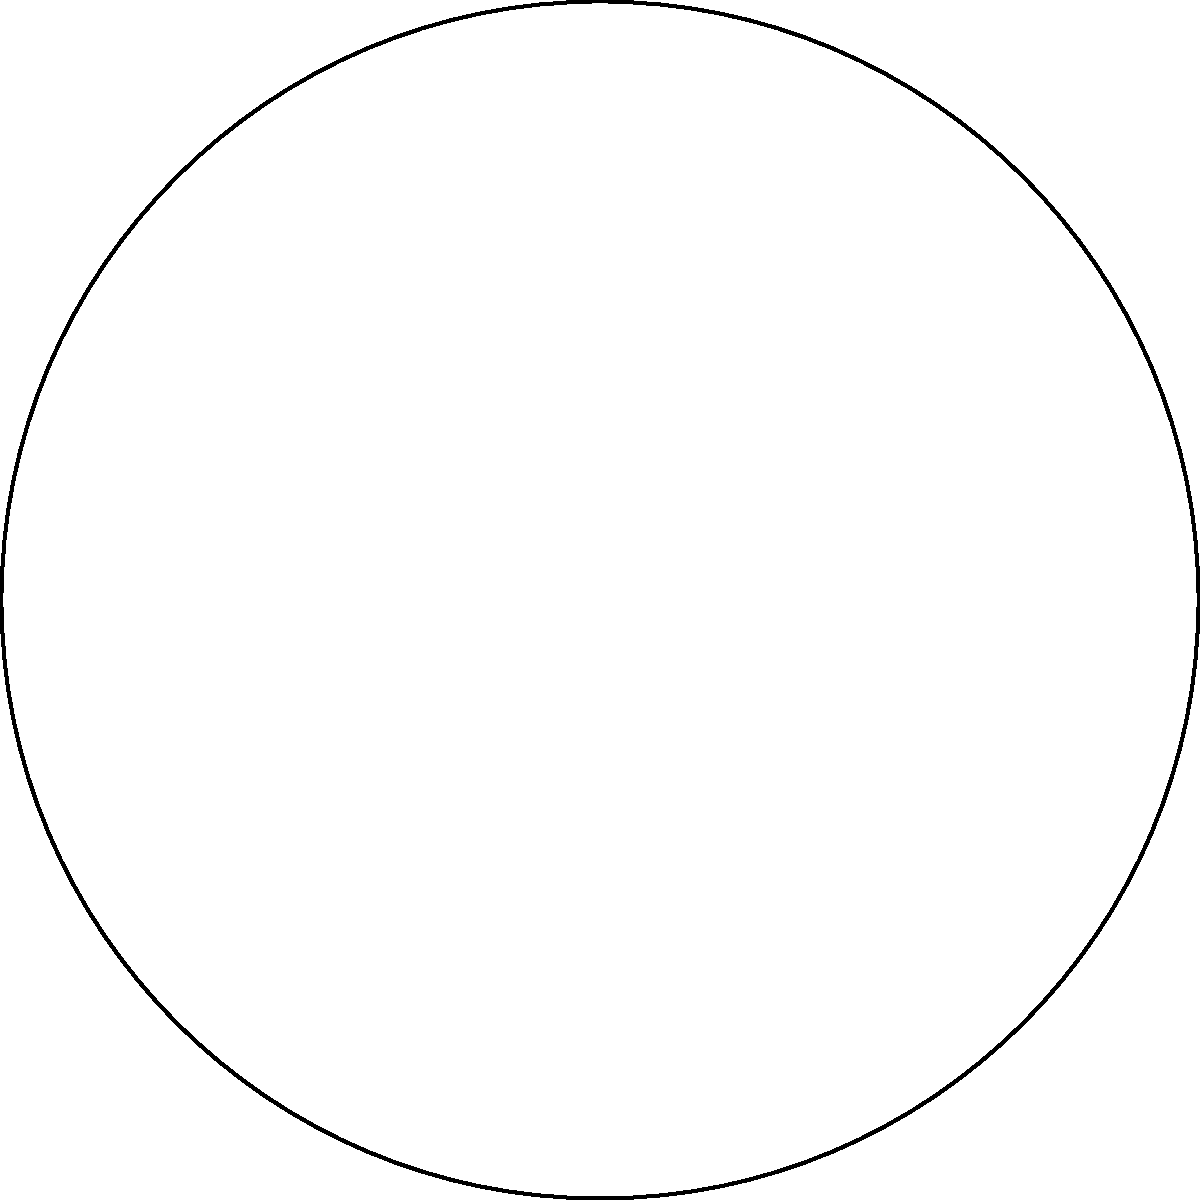On the Discworld, the Great A'Tuin is carrying two cities, Ankh-Morpork (A) and Quirm (B), located on the Circumfence. Ankh-Morpork is at 60° longitude, while Quirm is at 150° longitude. If the radius of the Discworld is 6,000 miles, what is the shortest distance along the Circumfence between these two cities? To solve this problem, we'll use the arc length formula for a circle. Here's how:

1) First, we need to find the central angle between the two points. 
   The central angle is the absolute difference between the longitudes:
   $|150° - 60°| = 90°$

2) Convert the angle to radians:
   $90° * \frac{\pi}{180°} = \frac{\pi}{2}$ radians

3) The arc length formula is: $s = r\theta$
   Where $s$ is the arc length, $r$ is the radius, and $\theta$ is the central angle in radians.

4) Plug in the values:
   $s = 6000 * \frac{\pi}{2}$

5) Simplify:
   $s = 3000\pi$ miles

This is the shortest distance along the Circumfence between Ankh-Morpork and Quirm.
Answer: $3000\pi$ miles 